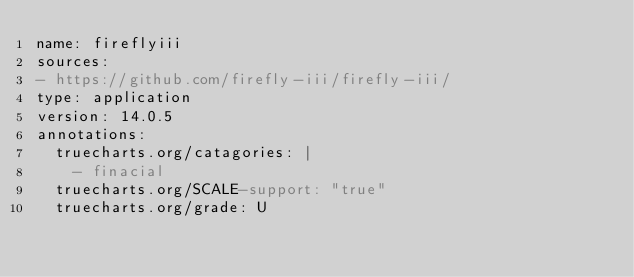Convert code to text. <code><loc_0><loc_0><loc_500><loc_500><_YAML_>name: fireflyiii
sources:
- https://github.com/firefly-iii/firefly-iii/
type: application
version: 14.0.5
annotations:
  truecharts.org/catagories: |
    - finacial
  truecharts.org/SCALE-support: "true"
  truecharts.org/grade: U
</code> 